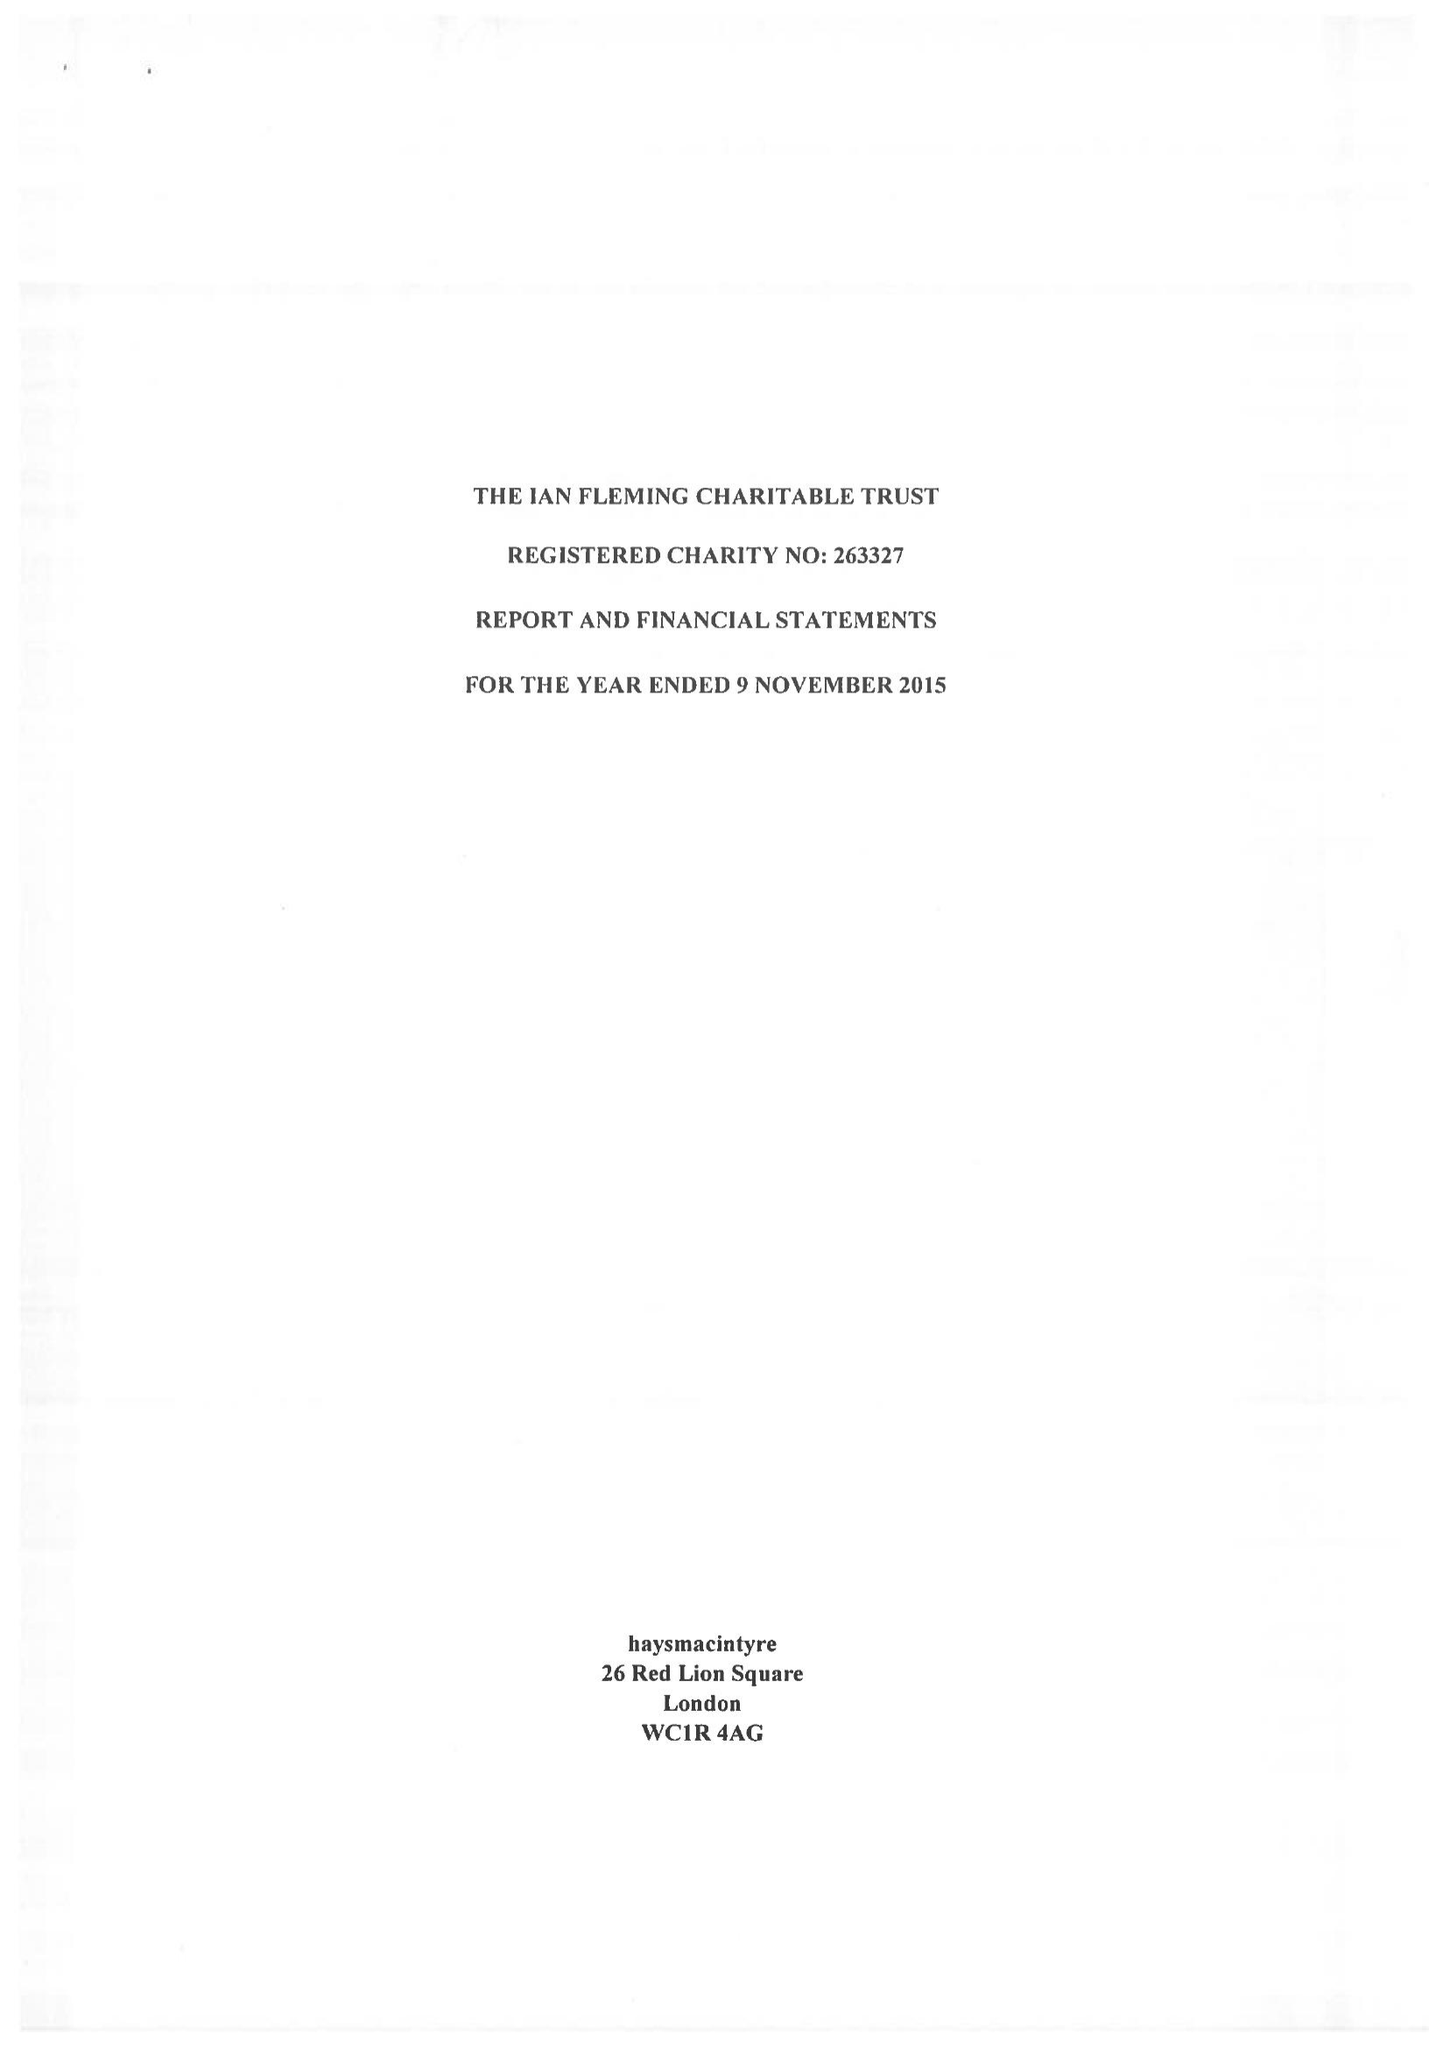What is the value for the report_date?
Answer the question using a single word or phrase. 2015-11-09 